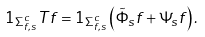Convert formula to latex. <formula><loc_0><loc_0><loc_500><loc_500>1 _ { \Sigma _ { f , s } ^ { c } } T f = 1 _ { \Sigma _ { f , s } ^ { c } } \left ( \tilde { \Phi } _ { s } f + \Psi _ { s } f \right ) .</formula> 